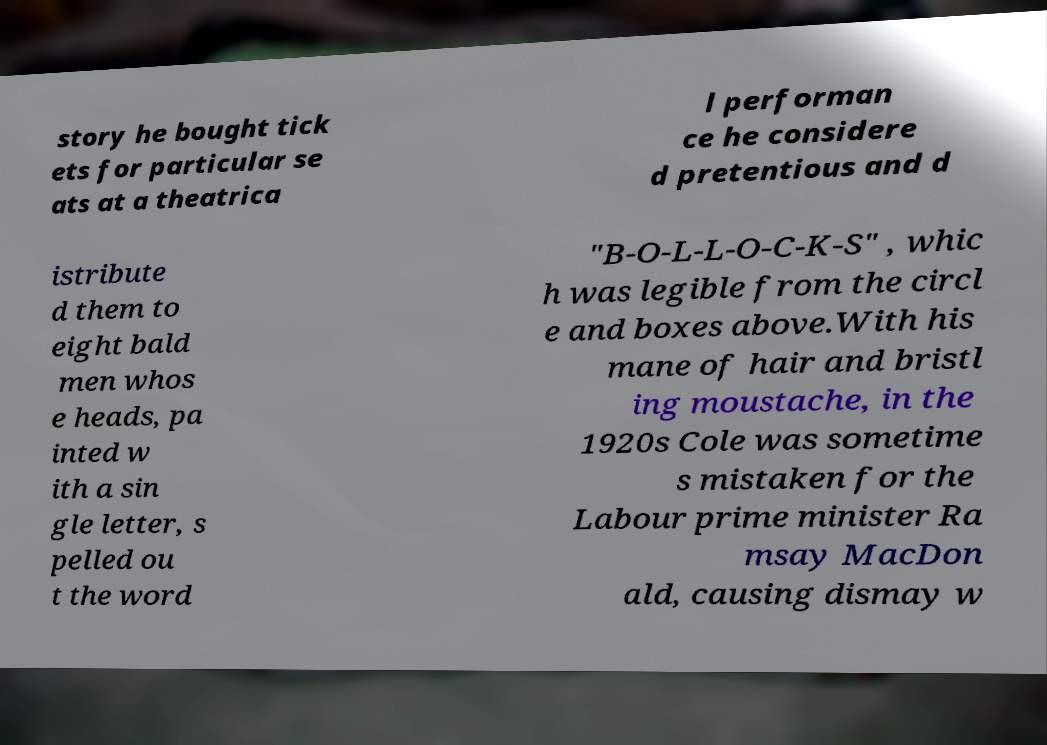For documentation purposes, I need the text within this image transcribed. Could you provide that? story he bought tick ets for particular se ats at a theatrica l performan ce he considere d pretentious and d istribute d them to eight bald men whos e heads, pa inted w ith a sin gle letter, s pelled ou t the word "B-O-L-L-O-C-K-S" , whic h was legible from the circl e and boxes above.With his mane of hair and bristl ing moustache, in the 1920s Cole was sometime s mistaken for the Labour prime minister Ra msay MacDon ald, causing dismay w 